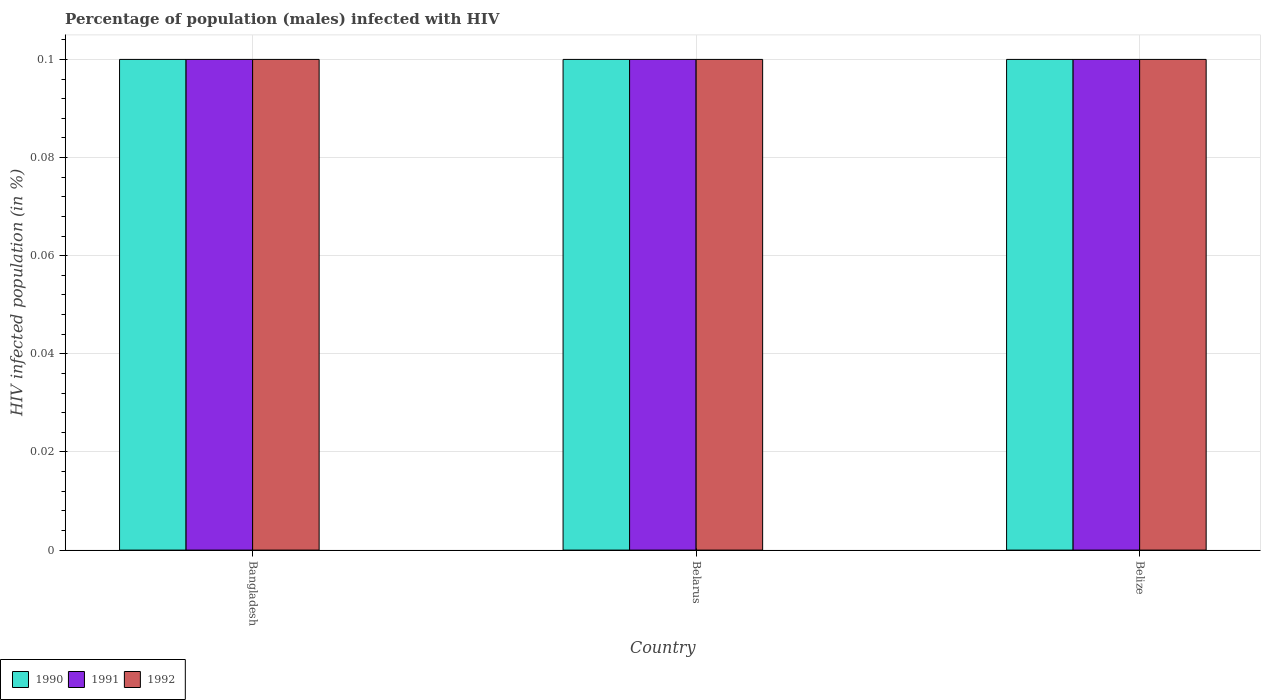How many different coloured bars are there?
Keep it short and to the point. 3. What is the label of the 3rd group of bars from the left?
Offer a very short reply. Belize. In how many cases, is the number of bars for a given country not equal to the number of legend labels?
Give a very brief answer. 0. What is the percentage of HIV infected male population in 1992 in Belarus?
Offer a terse response. 0.1. Across all countries, what is the maximum percentage of HIV infected male population in 1991?
Give a very brief answer. 0.1. Across all countries, what is the minimum percentage of HIV infected male population in 1990?
Your answer should be very brief. 0.1. In which country was the percentage of HIV infected male population in 1992 maximum?
Ensure brevity in your answer.  Bangladesh. In which country was the percentage of HIV infected male population in 1992 minimum?
Your response must be concise. Bangladesh. What is the total percentage of HIV infected male population in 1990 in the graph?
Your response must be concise. 0.3. What is the difference between the percentage of HIV infected male population in 1990 in Belarus and that in Belize?
Provide a succinct answer. 0. What is the average percentage of HIV infected male population in 1991 per country?
Provide a short and direct response. 0.1. What is the difference between the percentage of HIV infected male population of/in 1991 and percentage of HIV infected male population of/in 1990 in Belize?
Ensure brevity in your answer.  0. In how many countries, is the percentage of HIV infected male population in 1990 greater than 0.028 %?
Give a very brief answer. 3. What is the ratio of the percentage of HIV infected male population in 1990 in Belarus to that in Belize?
Provide a short and direct response. 1. Is the difference between the percentage of HIV infected male population in 1991 in Belarus and Belize greater than the difference between the percentage of HIV infected male population in 1990 in Belarus and Belize?
Give a very brief answer. No. In how many countries, is the percentage of HIV infected male population in 1992 greater than the average percentage of HIV infected male population in 1992 taken over all countries?
Give a very brief answer. 0. What does the 3rd bar from the left in Belize represents?
Your answer should be very brief. 1992. What does the 2nd bar from the right in Belize represents?
Your answer should be compact. 1991. How many bars are there?
Your response must be concise. 9. What is the difference between two consecutive major ticks on the Y-axis?
Your response must be concise. 0.02. Are the values on the major ticks of Y-axis written in scientific E-notation?
Your answer should be compact. No. Does the graph contain grids?
Keep it short and to the point. Yes. Where does the legend appear in the graph?
Ensure brevity in your answer.  Bottom left. How many legend labels are there?
Give a very brief answer. 3. How are the legend labels stacked?
Provide a short and direct response. Horizontal. What is the title of the graph?
Offer a terse response. Percentage of population (males) infected with HIV. Does "1977" appear as one of the legend labels in the graph?
Give a very brief answer. No. What is the label or title of the X-axis?
Keep it short and to the point. Country. What is the label or title of the Y-axis?
Your response must be concise. HIV infected population (in %). What is the HIV infected population (in %) of 1990 in Bangladesh?
Your answer should be compact. 0.1. What is the HIV infected population (in %) in 1991 in Bangladesh?
Keep it short and to the point. 0.1. What is the HIV infected population (in %) in 1991 in Belarus?
Your answer should be compact. 0.1. What is the HIV infected population (in %) in 1992 in Belarus?
Give a very brief answer. 0.1. Across all countries, what is the maximum HIV infected population (in %) of 1991?
Your answer should be compact. 0.1. Across all countries, what is the maximum HIV infected population (in %) of 1992?
Make the answer very short. 0.1. What is the total HIV infected population (in %) of 1990 in the graph?
Keep it short and to the point. 0.3. What is the total HIV infected population (in %) of 1991 in the graph?
Your answer should be compact. 0.3. What is the difference between the HIV infected population (in %) of 1991 in Bangladesh and that in Belarus?
Your answer should be compact. 0. What is the difference between the HIV infected population (in %) of 1992 in Bangladesh and that in Belarus?
Provide a short and direct response. 0. What is the difference between the HIV infected population (in %) of 1991 in Bangladesh and that in Belize?
Your answer should be very brief. 0. What is the difference between the HIV infected population (in %) in 1992 in Bangladesh and that in Belize?
Keep it short and to the point. 0. What is the difference between the HIV infected population (in %) in 1991 in Belarus and that in Belize?
Give a very brief answer. 0. What is the difference between the HIV infected population (in %) in 1990 in Bangladesh and the HIV infected population (in %) in 1992 in Belarus?
Offer a terse response. 0. What is the difference between the HIV infected population (in %) of 1990 in Bangladesh and the HIV infected population (in %) of 1991 in Belize?
Offer a very short reply. 0. What is the difference between the HIV infected population (in %) of 1990 in Belarus and the HIV infected population (in %) of 1992 in Belize?
Provide a short and direct response. 0. What is the difference between the HIV infected population (in %) of 1991 in Belarus and the HIV infected population (in %) of 1992 in Belize?
Offer a terse response. 0. What is the average HIV infected population (in %) of 1990 per country?
Your answer should be very brief. 0.1. What is the average HIV infected population (in %) of 1991 per country?
Offer a terse response. 0.1. What is the difference between the HIV infected population (in %) in 1990 and HIV infected population (in %) in 1991 in Bangladesh?
Ensure brevity in your answer.  0. What is the difference between the HIV infected population (in %) of 1991 and HIV infected population (in %) of 1992 in Bangladesh?
Your response must be concise. 0. What is the difference between the HIV infected population (in %) in 1990 and HIV infected population (in %) in 1991 in Belarus?
Give a very brief answer. 0. What is the difference between the HIV infected population (in %) of 1990 and HIV infected population (in %) of 1992 in Belarus?
Provide a succinct answer. 0. What is the difference between the HIV infected population (in %) of 1990 and HIV infected population (in %) of 1992 in Belize?
Offer a very short reply. 0. What is the ratio of the HIV infected population (in %) of 1992 in Bangladesh to that in Belarus?
Provide a succinct answer. 1. What is the ratio of the HIV infected population (in %) of 1990 in Bangladesh to that in Belize?
Offer a terse response. 1. What is the ratio of the HIV infected population (in %) of 1992 in Bangladesh to that in Belize?
Your answer should be compact. 1. What is the ratio of the HIV infected population (in %) of 1991 in Belarus to that in Belize?
Make the answer very short. 1. What is the ratio of the HIV infected population (in %) in 1992 in Belarus to that in Belize?
Provide a short and direct response. 1. What is the difference between the highest and the second highest HIV infected population (in %) of 1991?
Offer a terse response. 0. What is the difference between the highest and the lowest HIV infected population (in %) in 1991?
Ensure brevity in your answer.  0. 